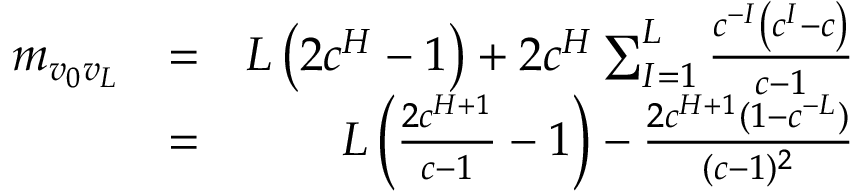<formula> <loc_0><loc_0><loc_500><loc_500>\begin{array} { r l r } { m _ { v _ { 0 } v _ { L } } } & { = } & { L \left ( 2 c ^ { H } - 1 \right ) + 2 c ^ { H } \sum _ { I = 1 } ^ { L } \frac { c ^ { - I } \left ( c ^ { I } - c \right ) } { c - 1 } } \\ & { = } & { L \left ( \frac { 2 c ^ { H + 1 } } { c - 1 } - 1 \right ) - \frac { 2 c ^ { H + 1 } ( 1 - c ^ { - L } ) } { ( c - 1 ) ^ { 2 } } } \end{array}</formula> 